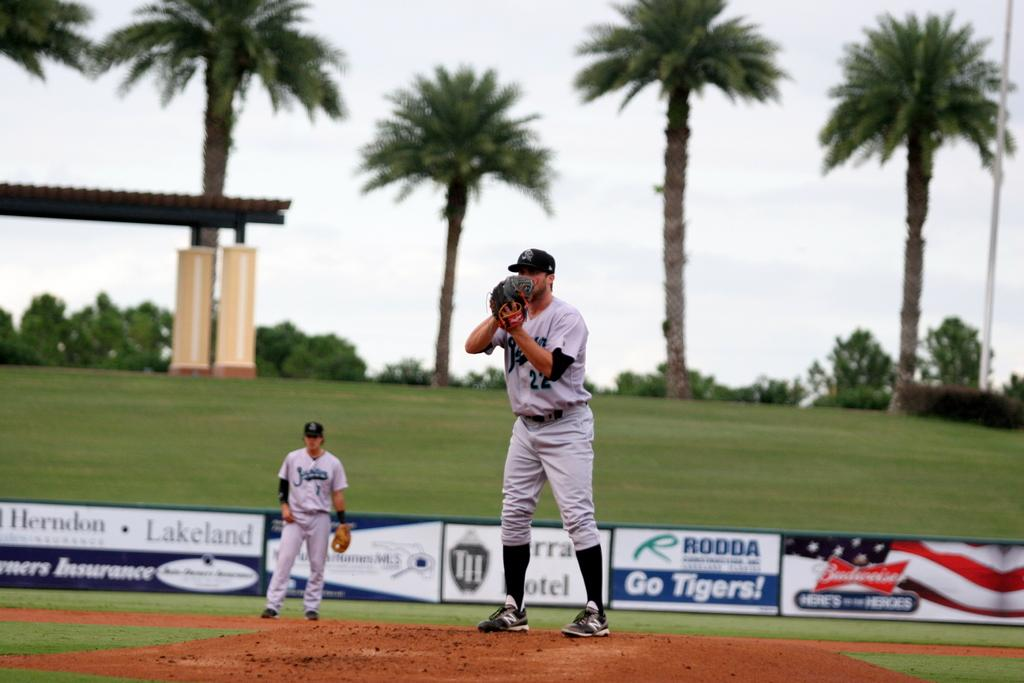<image>
Describe the image concisely. A baseball pitcher is on the mound with an advertisement for Budweiser behind him 